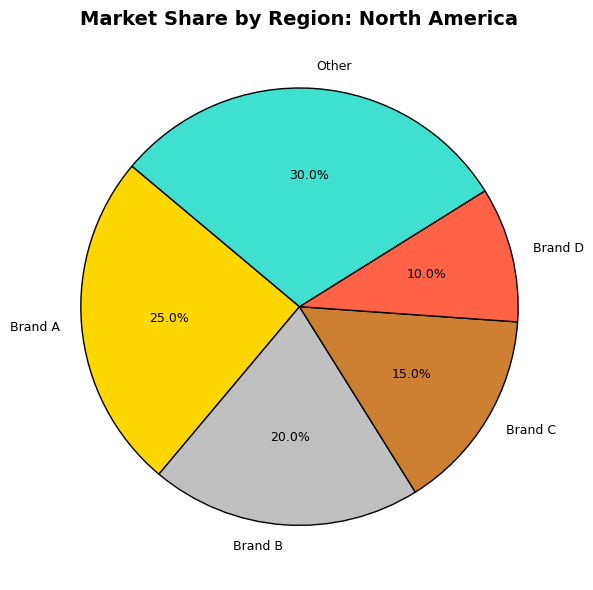What's the market share of Brand A in North America? Look at the pie chart for the North America region and find the slice labeled "Brand A." The label indicates a 25% market share.
Answer: 25% Which brand has the highest market share in Europe? Look at the pie chart for the Europe region and compare the sizes of the slices. The slice labeled "Brand A" is the largest, indicating a 30% market share, which is the highest.
Answer: Brand A What is the difference in market share between Brand B and Brand D in Asia? Look at the pie chart for the Asia region and find the slices labeled "Brand B" and "Brand D." Brand B has a 25% market share, and Brand D has a 15% share. The difference is 25% - 15% = 10%.
Answer: 10% What is the combined market share of other brands in Africa? Look at the pie chart for the Africa region and find the slice labeled "Other." The label shows a 50% market share. There is no need to combine further as "Other" already represents all brands not individually listed.
Answer: 50% Which region has the smallest market share for Brand C? Compare the sizes of the slices labeled "Brand C" from all regions. The smallest slice for Brand C is in the Middle East with a 15% market share.
Answer: Middle East Compare the market share of Brand A in North America and Europe. Which one is higher? Look at the pie charts for North America and Europe to find the slices labeled "Brand A." Brand A has a 25% market share in North America and a 30% market share in Europe. Therefore, Brand A has a higher market share in Europe.
Answer: Europe What is the average market share of Brand D across all regions? Find the slices labeled "Brand D" in each region: North America (10%), Europe (15%), Asia (15%), Middle East (10%), Africa (15%), and Latin America (10%). Then, calculate the average: (10% + 15% + 15% + 10% + 15% + 10%) / 6 = 12.5%.
Answer: 12.5% Which color representation is used for the "Other" category? Look at the pie charts and find the color used for the slices labeled "Other." In all regions, the "Other" categories are represented with turquoise in the charts.
Answer: turquoise Is there a region where no single brand has a market share higher than 25%? Look at all the pie charts to identify the largest slices. In Africa, no single brand has a market share exceeding 25%. The highest market share is 15% for both Brand C and Brand D.
Answer: Africa Which brand has the most balanced market share across all regions? Compare the market shares of each brand across all regions. Brand A has market shares of 25%, 30%, 20%, 35%, 10%, and 20% across the regions respectively. This brand appears to have the most balanced distribution relative to the other brands.
Answer: Brand A 